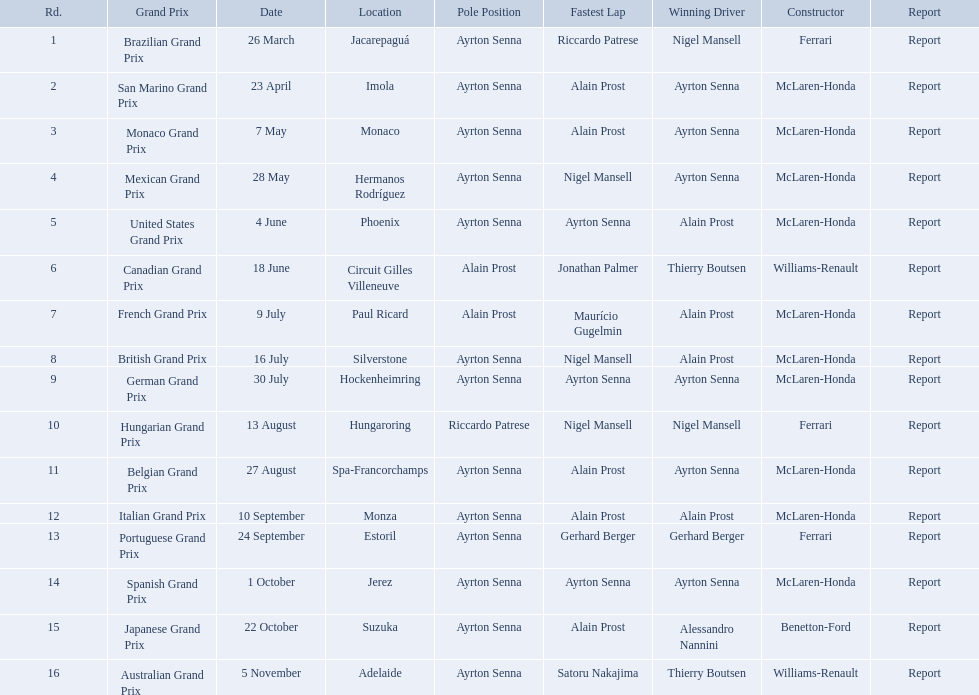What are all of the grand prix run in the 1989 formula one season? Brazilian Grand Prix, San Marino Grand Prix, Monaco Grand Prix, Mexican Grand Prix, United States Grand Prix, Canadian Grand Prix, French Grand Prix, British Grand Prix, German Grand Prix, Hungarian Grand Prix, Belgian Grand Prix, Italian Grand Prix, Portuguese Grand Prix, Spanish Grand Prix, Japanese Grand Prix, Australian Grand Prix. Of those 1989 formula one grand prix, which were run in october? Spanish Grand Prix, Japanese Grand Prix, Australian Grand Prix. Of those 1989 formula one grand prix run in october, which was the only one to be won by benetton-ford? Japanese Grand Prix. What are the entire set of grand prix events during the 1989 formula one season? Brazilian Grand Prix, San Marino Grand Prix, Monaco Grand Prix, Mexican Grand Prix, United States Grand Prix, Canadian Grand Prix, French Grand Prix, British Grand Prix, German Grand Prix, Hungarian Grand Prix, Belgian Grand Prix, Italian Grand Prix, Portuguese Grand Prix, Spanish Grand Prix, Japanese Grand Prix, Australian Grand Prix. Among the 1989 formula one grand prix, which were held in october? Spanish Grand Prix, Japanese Grand Prix, Australian Grand Prix. Of those 1989 formula one grand prix that took place in october, which was the exclusive one won by benetton-ford? Japanese Grand Prix. Who are the builders in the 1989 formula one season? Ferrari, McLaren-Honda, McLaren-Honda, McLaren-Honda, McLaren-Honda, Williams-Renault, McLaren-Honda, McLaren-Honda, McLaren-Honda, Ferrari, McLaren-Honda, McLaren-Honda, Ferrari, McLaren-Honda, Benetton-Ford, Williams-Renault. On what date was bennington ford the builder? 22 October. What was the competition on october 22? Japanese Grand Prix. Who claimed victory in the spanish grand prix? McLaren-Honda. Who succeeded in the italian grand prix? McLaren-Honda. What grand prix did benneton-ford emerge victorious in? Japanese Grand Prix. What are all the grand prix races conducted in the 1989 formula one season? Brazilian Grand Prix, San Marino Grand Prix, Monaco Grand Prix, Mexican Grand Prix, United States Grand Prix, Canadian Grand Prix, French Grand Prix, British Grand Prix, German Grand Prix, Hungarian Grand Prix, Belgian Grand Prix, Italian Grand Prix, Portuguese Grand Prix, Spanish Grand Prix, Japanese Grand Prix, Australian Grand Prix. Of these 1989 formula one grand prix, which occurred in october? Spanish Grand Prix, Japanese Grand Prix, Australian Grand Prix. Of the 1989 formula one grand prix that happened in october, which was the only one where benetton-ford emerged victorious? Japanese Grand Prix. Who are the manufacturers in the 1989 formula one season? Ferrari, McLaren-Honda, McLaren-Honda, McLaren-Honda, McLaren-Honda, Williams-Renault, McLaren-Honda, McLaren-Honda, McLaren-Honda, Ferrari, McLaren-Honda, McLaren-Honda, Ferrari, McLaren-Honda, Benetton-Ford, Williams-Renault. On what date was bennington ford the manufacturer? 22 October. What was the event on october 22? Japanese Grand Prix. Parse the full table in json format. {'header': ['Rd.', 'Grand Prix', 'Date', 'Location', 'Pole Position', 'Fastest Lap', 'Winning Driver', 'Constructor', 'Report'], 'rows': [['1', 'Brazilian Grand Prix', '26 March', 'Jacarepaguá', 'Ayrton Senna', 'Riccardo Patrese', 'Nigel Mansell', 'Ferrari', 'Report'], ['2', 'San Marino Grand Prix', '23 April', 'Imola', 'Ayrton Senna', 'Alain Prost', 'Ayrton Senna', 'McLaren-Honda', 'Report'], ['3', 'Monaco Grand Prix', '7 May', 'Monaco', 'Ayrton Senna', 'Alain Prost', 'Ayrton Senna', 'McLaren-Honda', 'Report'], ['4', 'Mexican Grand Prix', '28 May', 'Hermanos Rodríguez', 'Ayrton Senna', 'Nigel Mansell', 'Ayrton Senna', 'McLaren-Honda', 'Report'], ['5', 'United States Grand Prix', '4 June', 'Phoenix', 'Ayrton Senna', 'Ayrton Senna', 'Alain Prost', 'McLaren-Honda', 'Report'], ['6', 'Canadian Grand Prix', '18 June', 'Circuit Gilles Villeneuve', 'Alain Prost', 'Jonathan Palmer', 'Thierry Boutsen', 'Williams-Renault', 'Report'], ['7', 'French Grand Prix', '9 July', 'Paul Ricard', 'Alain Prost', 'Maurício Gugelmin', 'Alain Prost', 'McLaren-Honda', 'Report'], ['8', 'British Grand Prix', '16 July', 'Silverstone', 'Ayrton Senna', 'Nigel Mansell', 'Alain Prost', 'McLaren-Honda', 'Report'], ['9', 'German Grand Prix', '30 July', 'Hockenheimring', 'Ayrton Senna', 'Ayrton Senna', 'Ayrton Senna', 'McLaren-Honda', 'Report'], ['10', 'Hungarian Grand Prix', '13 August', 'Hungaroring', 'Riccardo Patrese', 'Nigel Mansell', 'Nigel Mansell', 'Ferrari', 'Report'], ['11', 'Belgian Grand Prix', '27 August', 'Spa-Francorchamps', 'Ayrton Senna', 'Alain Prost', 'Ayrton Senna', 'McLaren-Honda', 'Report'], ['12', 'Italian Grand Prix', '10 September', 'Monza', 'Ayrton Senna', 'Alain Prost', 'Alain Prost', 'McLaren-Honda', 'Report'], ['13', 'Portuguese Grand Prix', '24 September', 'Estoril', 'Ayrton Senna', 'Gerhard Berger', 'Gerhard Berger', 'Ferrari', 'Report'], ['14', 'Spanish Grand Prix', '1 October', 'Jerez', 'Ayrton Senna', 'Ayrton Senna', 'Ayrton Senna', 'McLaren-Honda', 'Report'], ['15', 'Japanese Grand Prix', '22 October', 'Suzuka', 'Ayrton Senna', 'Alain Prost', 'Alessandro Nannini', 'Benetton-Ford', 'Report'], ['16', 'Australian Grand Prix', '5 November', 'Adelaide', 'Ayrton Senna', 'Satoru Nakajima', 'Thierry Boutsen', 'Williams-Renault', 'Report']]} Who came out on top in the spanish grand prix? McLaren-Honda. Who was the winner of the italian grand prix? McLaren-Honda. Can you give me this table as a dict? {'header': ['Rd.', 'Grand Prix', 'Date', 'Location', 'Pole Position', 'Fastest Lap', 'Winning Driver', 'Constructor', 'Report'], 'rows': [['1', 'Brazilian Grand Prix', '26 March', 'Jacarepaguá', 'Ayrton Senna', 'Riccardo Patrese', 'Nigel Mansell', 'Ferrari', 'Report'], ['2', 'San Marino Grand Prix', '23 April', 'Imola', 'Ayrton Senna', 'Alain Prost', 'Ayrton Senna', 'McLaren-Honda', 'Report'], ['3', 'Monaco Grand Prix', '7 May', 'Monaco', 'Ayrton Senna', 'Alain Prost', 'Ayrton Senna', 'McLaren-Honda', 'Report'], ['4', 'Mexican Grand Prix', '28 May', 'Hermanos Rodríguez', 'Ayrton Senna', 'Nigel Mansell', 'Ayrton Senna', 'McLaren-Honda', 'Report'], ['5', 'United States Grand Prix', '4 June', 'Phoenix', 'Ayrton Senna', 'Ayrton Senna', 'Alain Prost', 'McLaren-Honda', 'Report'], ['6', 'Canadian Grand Prix', '18 June', 'Circuit Gilles Villeneuve', 'Alain Prost', 'Jonathan Palmer', 'Thierry Boutsen', 'Williams-Renault', 'Report'], ['7', 'French Grand Prix', '9 July', 'Paul Ricard', 'Alain Prost', 'Maurício Gugelmin', 'Alain Prost', 'McLaren-Honda', 'Report'], ['8', 'British Grand Prix', '16 July', 'Silverstone', 'Ayrton Senna', 'Nigel Mansell', 'Alain Prost', 'McLaren-Honda', 'Report'], ['9', 'German Grand Prix', '30 July', 'Hockenheimring', 'Ayrton Senna', 'Ayrton Senna', 'Ayrton Senna', 'McLaren-Honda', 'Report'], ['10', 'Hungarian Grand Prix', '13 August', 'Hungaroring', 'Riccardo Patrese', 'Nigel Mansell', 'Nigel Mansell', 'Ferrari', 'Report'], ['11', 'Belgian Grand Prix', '27 August', 'Spa-Francorchamps', 'Ayrton Senna', 'Alain Prost', 'Ayrton Senna', 'McLaren-Honda', 'Report'], ['12', 'Italian Grand Prix', '10 September', 'Monza', 'Ayrton Senna', 'Alain Prost', 'Alain Prost', 'McLaren-Honda', 'Report'], ['13', 'Portuguese Grand Prix', '24 September', 'Estoril', 'Ayrton Senna', 'Gerhard Berger', 'Gerhard Berger', 'Ferrari', 'Report'], ['14', 'Spanish Grand Prix', '1 October', 'Jerez', 'Ayrton Senna', 'Ayrton Senna', 'Ayrton Senna', 'McLaren-Honda', 'Report'], ['15', 'Japanese Grand Prix', '22 October', 'Suzuka', 'Ayrton Senna', 'Alain Prost', 'Alessandro Nannini', 'Benetton-Ford', 'Report'], ['16', 'Australian Grand Prix', '5 November', 'Adelaide', 'Ayrton Senna', 'Satoru Nakajima', 'Thierry Boutsen', 'Williams-Renault', 'Report']]} In which grand prix did benneton-ford achieve victory? Japanese Grand Prix. 